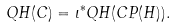Convert formula to latex. <formula><loc_0><loc_0><loc_500><loc_500>Q H ( C ) = \iota ^ { * } Q H ( C P ( H ) ) .</formula> 